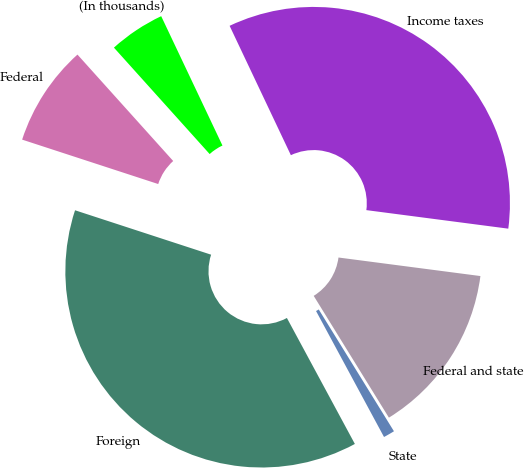Convert chart. <chart><loc_0><loc_0><loc_500><loc_500><pie_chart><fcel>(In thousands)<fcel>Federal<fcel>Foreign<fcel>State<fcel>Federal and state<fcel>Income taxes<nl><fcel>4.62%<fcel>8.32%<fcel>37.9%<fcel>0.93%<fcel>14.13%<fcel>34.11%<nl></chart> 